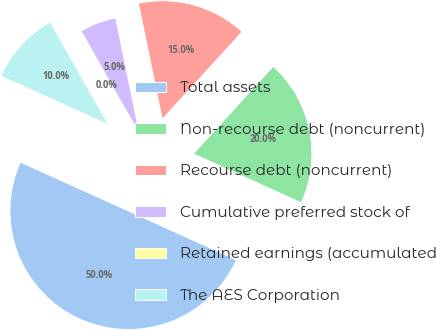<chart> <loc_0><loc_0><loc_500><loc_500><pie_chart><fcel>Total assets<fcel>Non-recourse debt (noncurrent)<fcel>Recourse debt (noncurrent)<fcel>Cumulative preferred stock of<fcel>Retained earnings (accumulated<fcel>The AES Corporation<nl><fcel>49.98%<fcel>20.0%<fcel>15.0%<fcel>5.01%<fcel>0.01%<fcel>10.0%<nl></chart> 